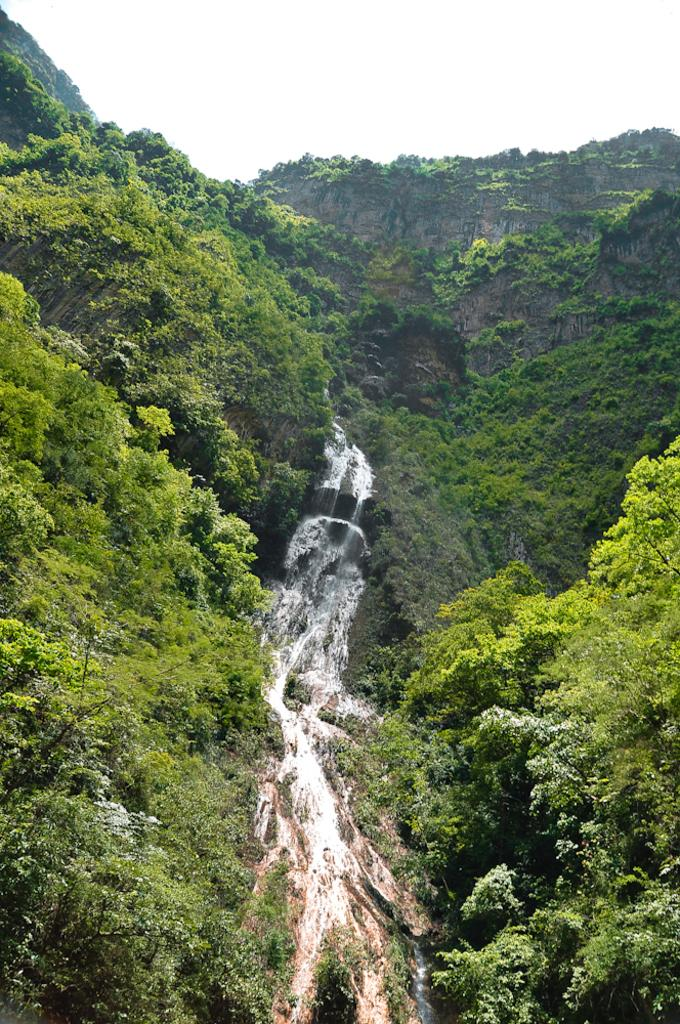What natural feature is the main subject of the image? There is a waterfall in the image. What type of vegetation can be seen on the hills in the image? There are trees on the hills on either side of the image. What is visible in the background of the image? The sky is visible in the background of the image. How many wishes can be granted by the waterfall in the image? There is no mention of wishes or any magical properties associated with the waterfall in the image. The waterfall is a natural feature and does not have the ability to grant wishes. 